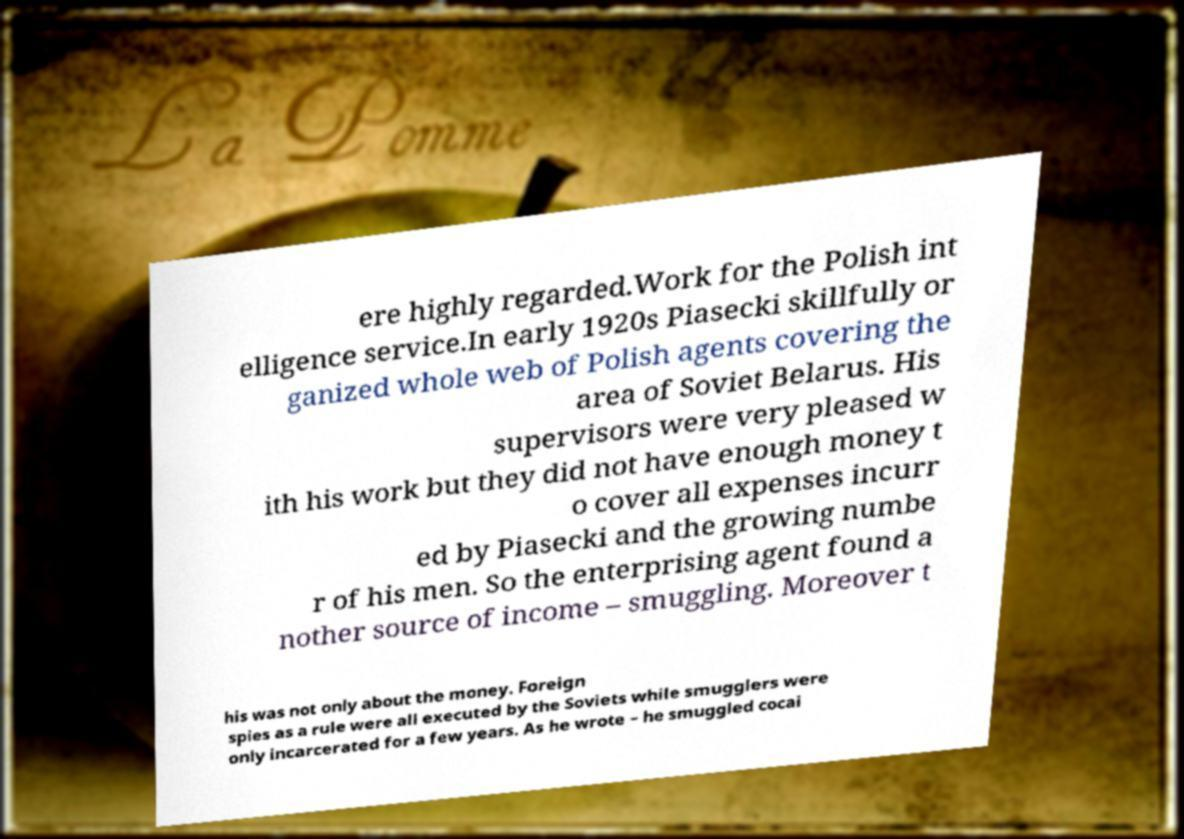Please identify and transcribe the text found in this image. ere highly regarded.Work for the Polish int elligence service.In early 1920s Piasecki skillfully or ganized whole web of Polish agents covering the area of Soviet Belarus. His supervisors were very pleased w ith his work but they did not have enough money t o cover all expenses incurr ed by Piasecki and the growing numbe r of his men. So the enterprising agent found a nother source of income – smuggling. Moreover t his was not only about the money. Foreign spies as a rule were all executed by the Soviets while smugglers were only incarcerated for a few years. As he wrote – he smuggled cocai 